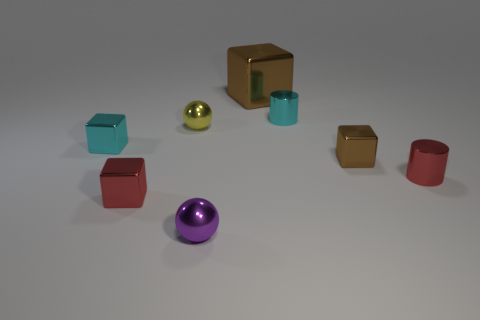Add 2 large blocks. How many objects exist? 10 Subtract all cylinders. How many objects are left? 6 Add 7 brown metal things. How many brown metal things exist? 9 Subtract 0 blue cylinders. How many objects are left? 8 Subtract all big purple rubber cylinders. Subtract all small brown metal objects. How many objects are left? 7 Add 7 tiny cyan cubes. How many tiny cyan cubes are left? 8 